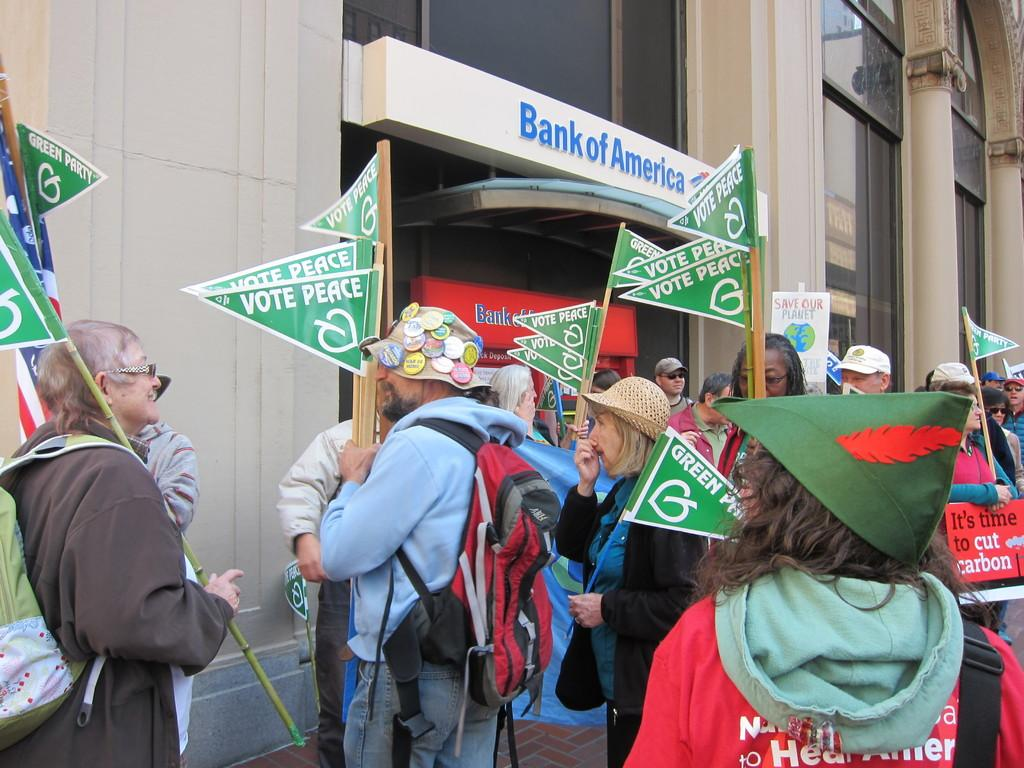What are the people near the building doing? The people standing near the building are holding flags. What can be seen on the building? There is text written on the building. Can you describe the people's actions in more detail? The people are holding flags, which suggests they might be participating in a ceremony or event. What type of lace can be seen on the building in the image? There is no lace present on the building in the image. Can you describe the goldfish swimming near the people in the image? There are no goldfish present in the image; it only features people holding flags near a building with text on it. 